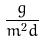Convert formula to latex. <formula><loc_0><loc_0><loc_500><loc_500>\frac { g } { m ^ { 2 } d }</formula> 